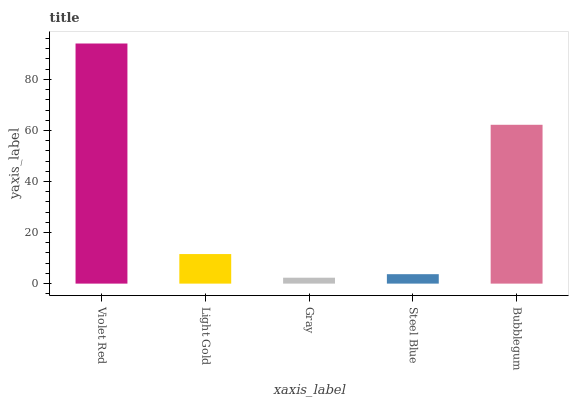Is Light Gold the minimum?
Answer yes or no. No. Is Light Gold the maximum?
Answer yes or no. No. Is Violet Red greater than Light Gold?
Answer yes or no. Yes. Is Light Gold less than Violet Red?
Answer yes or no. Yes. Is Light Gold greater than Violet Red?
Answer yes or no. No. Is Violet Red less than Light Gold?
Answer yes or no. No. Is Light Gold the high median?
Answer yes or no. Yes. Is Light Gold the low median?
Answer yes or no. Yes. Is Steel Blue the high median?
Answer yes or no. No. Is Bubblegum the low median?
Answer yes or no. No. 